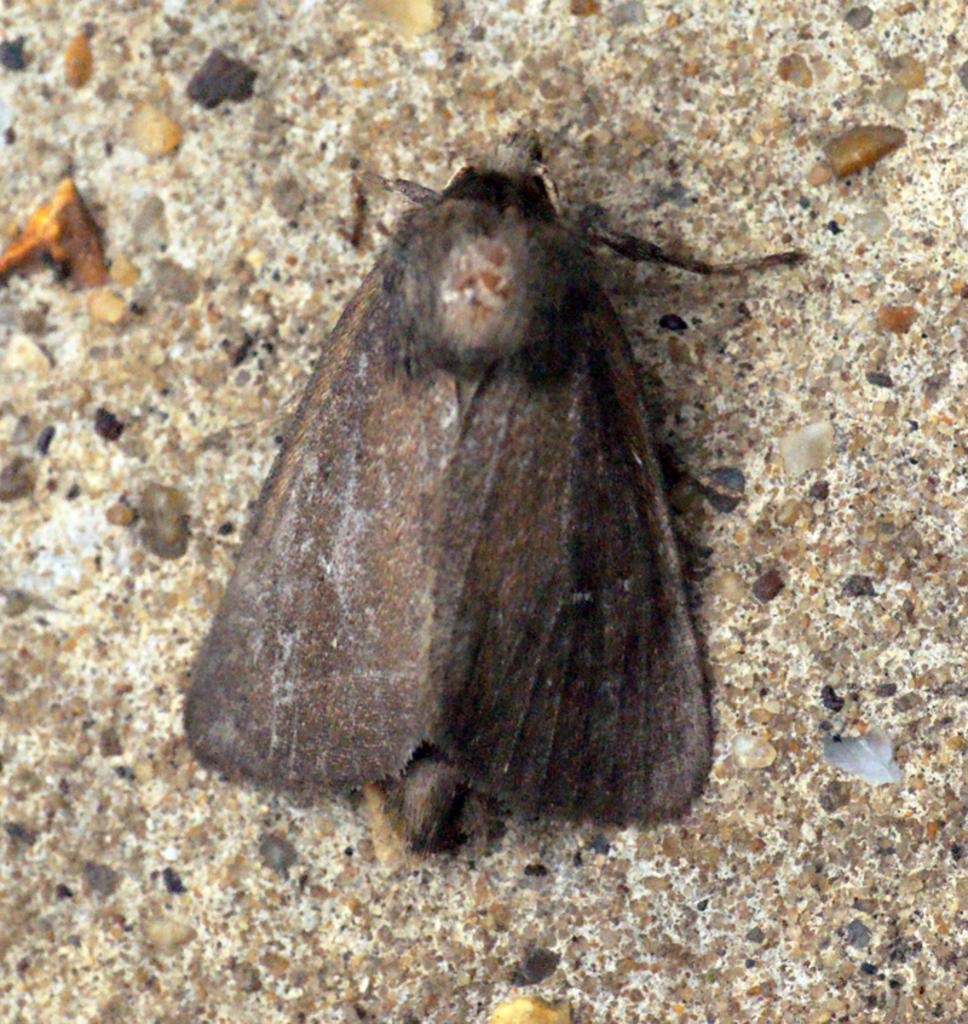What type of living organism can be seen in the image? There is an insect in the image. What type of vegetable is being used as a caption for the insect in the image? There is no vegetable or caption present in the image; it only features an insect. 